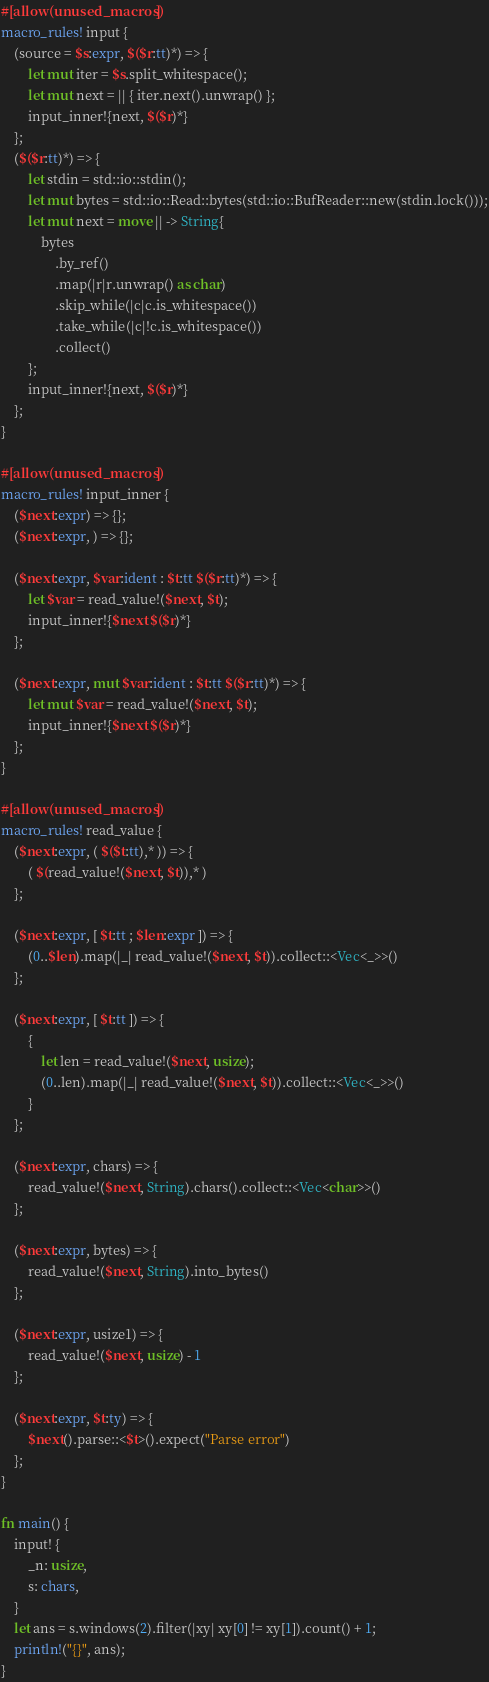Convert code to text. <code><loc_0><loc_0><loc_500><loc_500><_Rust_>#[allow(unused_macros)]
macro_rules! input {
    (source = $s:expr, $($r:tt)*) => {
        let mut iter = $s.split_whitespace();
        let mut next = || { iter.next().unwrap() };
        input_inner!{next, $($r)*}
    };
    ($($r:tt)*) => {
        let stdin = std::io::stdin();
        let mut bytes = std::io::Read::bytes(std::io::BufReader::new(stdin.lock()));
        let mut next = move || -> String{
            bytes
                .by_ref()
                .map(|r|r.unwrap() as char)
                .skip_while(|c|c.is_whitespace())
                .take_while(|c|!c.is_whitespace())
                .collect()
        };
        input_inner!{next, $($r)*}
    };
}

#[allow(unused_macros)]
macro_rules! input_inner {
    ($next:expr) => {};
    ($next:expr, ) => {};

    ($next:expr, $var:ident : $t:tt $($r:tt)*) => {
        let $var = read_value!($next, $t);
        input_inner!{$next $($r)*}
    };

    ($next:expr, mut $var:ident : $t:tt $($r:tt)*) => {
        let mut $var = read_value!($next, $t);
        input_inner!{$next $($r)*}
    };
}

#[allow(unused_macros)]
macro_rules! read_value {
    ($next:expr, ( $($t:tt),* )) => {
        ( $(read_value!($next, $t)),* )
    };

    ($next:expr, [ $t:tt ; $len:expr ]) => {
        (0..$len).map(|_| read_value!($next, $t)).collect::<Vec<_>>()
    };

    ($next:expr, [ $t:tt ]) => {
        {
            let len = read_value!($next, usize);
            (0..len).map(|_| read_value!($next, $t)).collect::<Vec<_>>()
        }
    };

    ($next:expr, chars) => {
        read_value!($next, String).chars().collect::<Vec<char>>()
    };

    ($next:expr, bytes) => {
        read_value!($next, String).into_bytes()
    };

    ($next:expr, usize1) => {
        read_value!($next, usize) - 1
    };

    ($next:expr, $t:ty) => {
        $next().parse::<$t>().expect("Parse error")
    };
}

fn main() {
    input! {
        _n: usize,
        s: chars,
    }
    let ans = s.windows(2).filter(|xy| xy[0] != xy[1]).count() + 1;
    println!("{}", ans);
}
</code> 